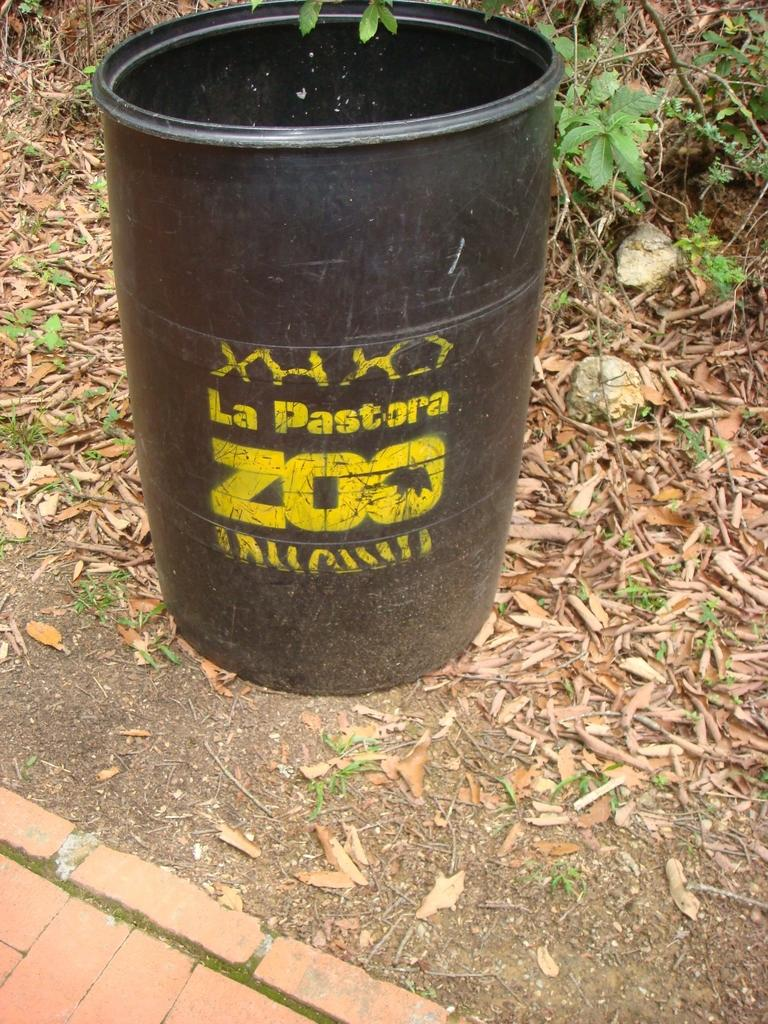<image>
Summarize the visual content of the image. the word zoo that is on a black bin 